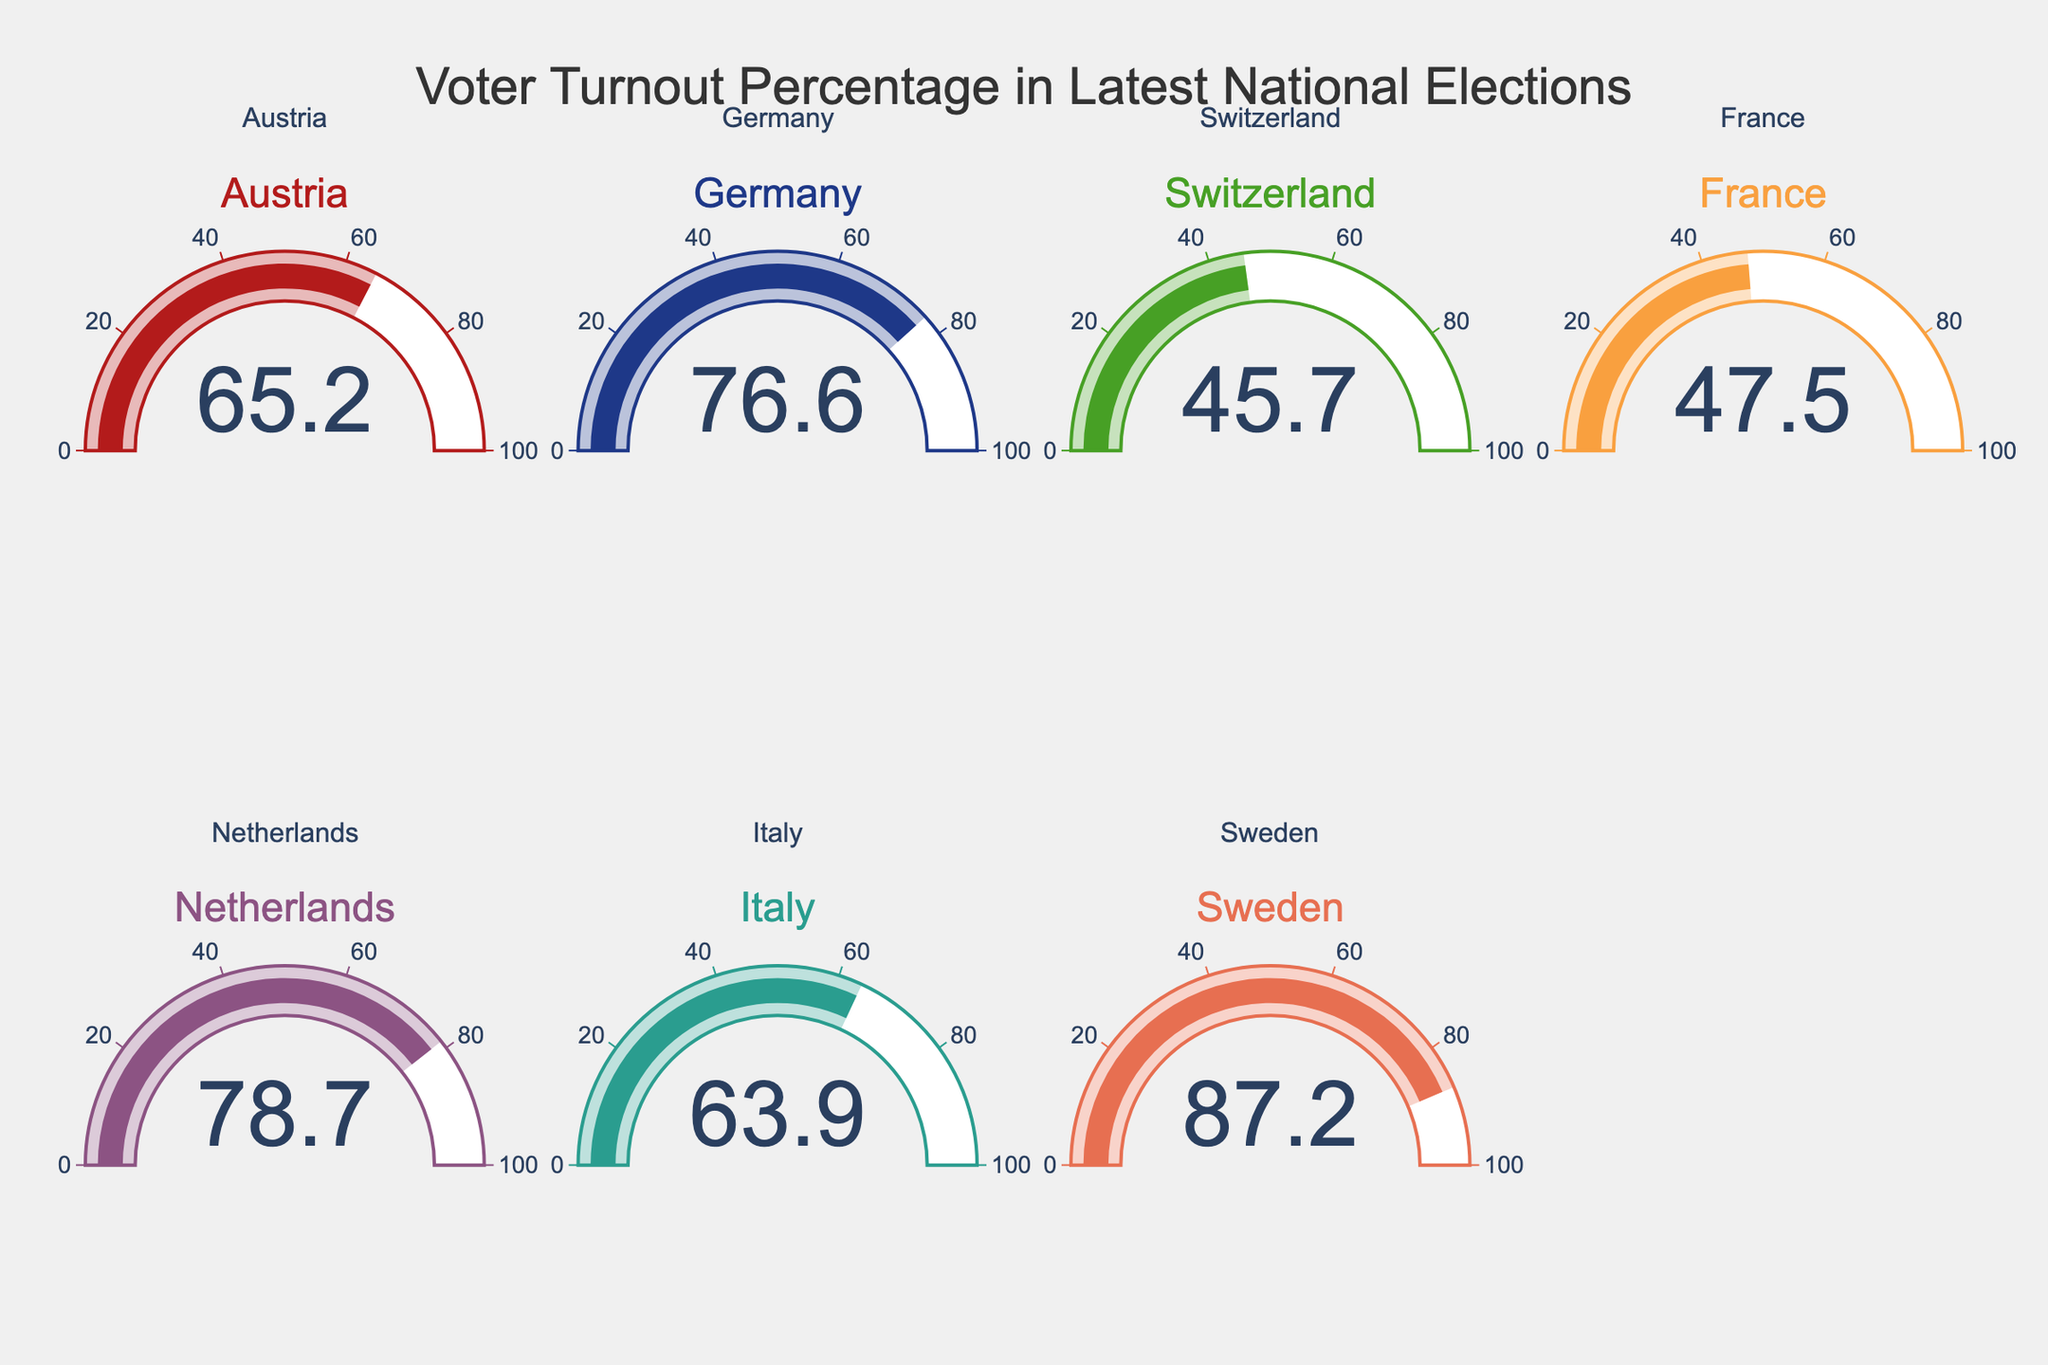Which country has the highest voter turnout percentage? From the gauge chart, the country with the highest voter turnout percentage is the one where the gauge needle points to the maximum value. The country with the highest value is shown by the gauge pointing to around 87.2%.
Answer: Sweden Which countries have a voter turnout percentage below 50%? From the gauge chart, the countries with a voter turnout percentage below 50% are those where the gauge needle points to a value less than 50%. These countries show gauges pointing to around 45.7% and 47.5%.
Answer: Switzerland and France What is the average voter turnout percentage among the displayed countries? Calculate the average of the voter turnout percentages shown on the gauges: (65.2 + 76.6 + 45.7 + 47.5 + 78.7 + 63.9 + 87.2) / 7. The sum is 464.8, and dividing by 7 gives the average.
Answer: 66.4 Which country has the lowest voter turnout percentage? From the gauge chart, the country with the lowest voter turnout percentage is the one where the gauge needle points to the minimum value. The country with the lowest value is shown by the gauge pointing to around 45.7%.
Answer: Switzerland How does Sweden's voter turnout compare to Italy's? From the gauge chart, Sweden's voter turnout percentage is around 87.2%, while Italy's is about 63.9%. Comparing the two percentages, Sweden's turnout is higher by 87.2 - 63.9.
Answer: 23.3% higher What is the range of voter turnout percentages displayed in the figure? The range is found by subtracting the lowest voter turnout percentage from the highest. The highest is 87.2% (Sweden) and the lowest is 45.7% (Switzerland), and their difference is 87.2 - 45.7.
Answer: 41.5% If Austria increased its voter turnout by 10%, what would the new percentage be? Austria's current voter turnout is 65.2%. Adding 10% to this value gives 65.2 + 10.
Answer: 75.2% Which countries have a voter turnout percentage within 5% of each other? Look for countries with very close voter turnout percentages on the gauge charts. France and Switzerland have percentages that are 47.5% and 45.7% respectively, within 5% of each other.
Answer: France and Switzerland If the voter turnout of Netherlands decreased by 15%, what would the new percentage be? The Netherlands' current voter turnout is 78.7%. Decreasing this by 15% of 78.7, which is 0.15 * 78.7 = 11.805, means the new percentage is 78.7 - 11.805.
Answer: 66.9 Which three countries have the highest voter turnout percentages? Identify the top three values from the gauge chart: Sweden (87.2%), Netherlands (78.7%), and Germany (76.6%).
Answer: Sweden, Netherlands, Germany 